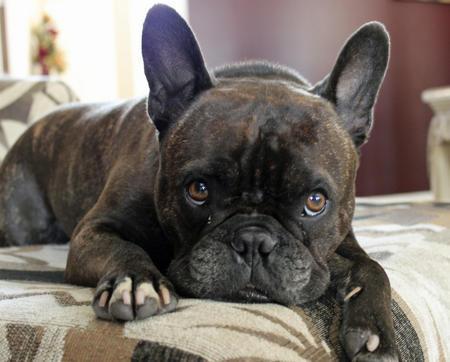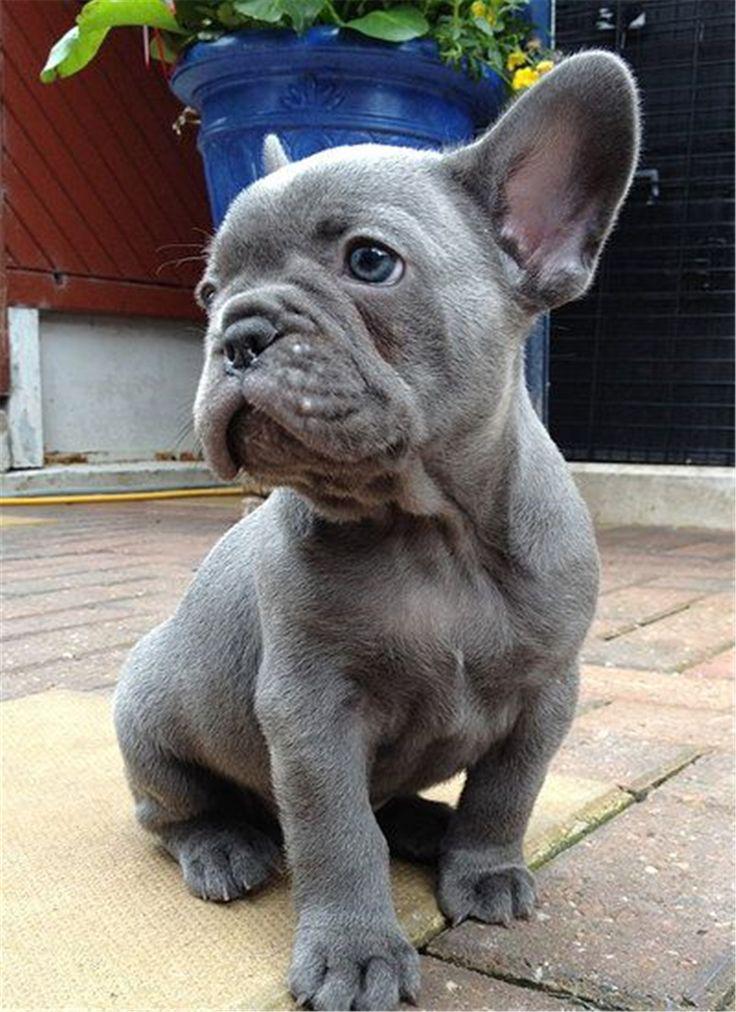The first image is the image on the left, the second image is the image on the right. For the images shown, is this caption "A dog is standing on grass in one image and a dog is on the couch in the other." true? Answer yes or no. No. The first image is the image on the left, the second image is the image on the right. Examine the images to the left and right. Is the description "The dog in the right image has its mouth open and its tongue out." accurate? Answer yes or no. No. 